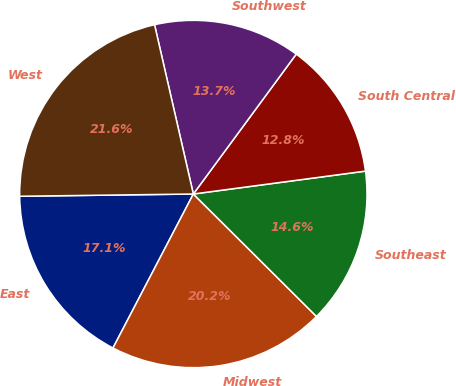Convert chart. <chart><loc_0><loc_0><loc_500><loc_500><pie_chart><fcel>East<fcel>Midwest<fcel>Southeast<fcel>South Central<fcel>Southwest<fcel>West<nl><fcel>17.14%<fcel>20.2%<fcel>14.56%<fcel>12.8%<fcel>13.68%<fcel>21.62%<nl></chart> 